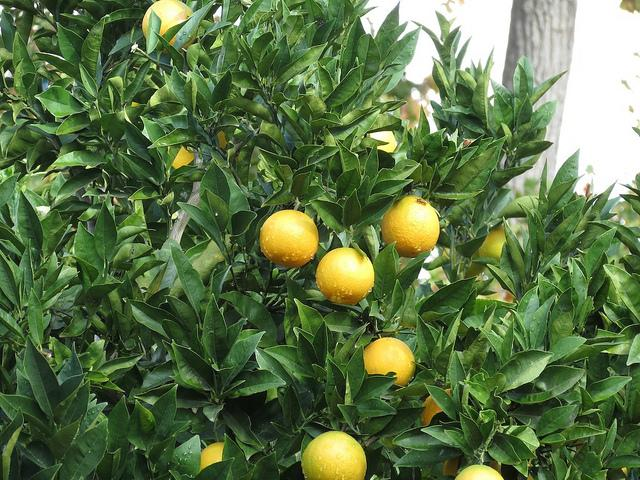What type of fruit is most likely on the tree?

Choices:
A) lime
B) dragonfruit
C) apple
D) lemon lemon 